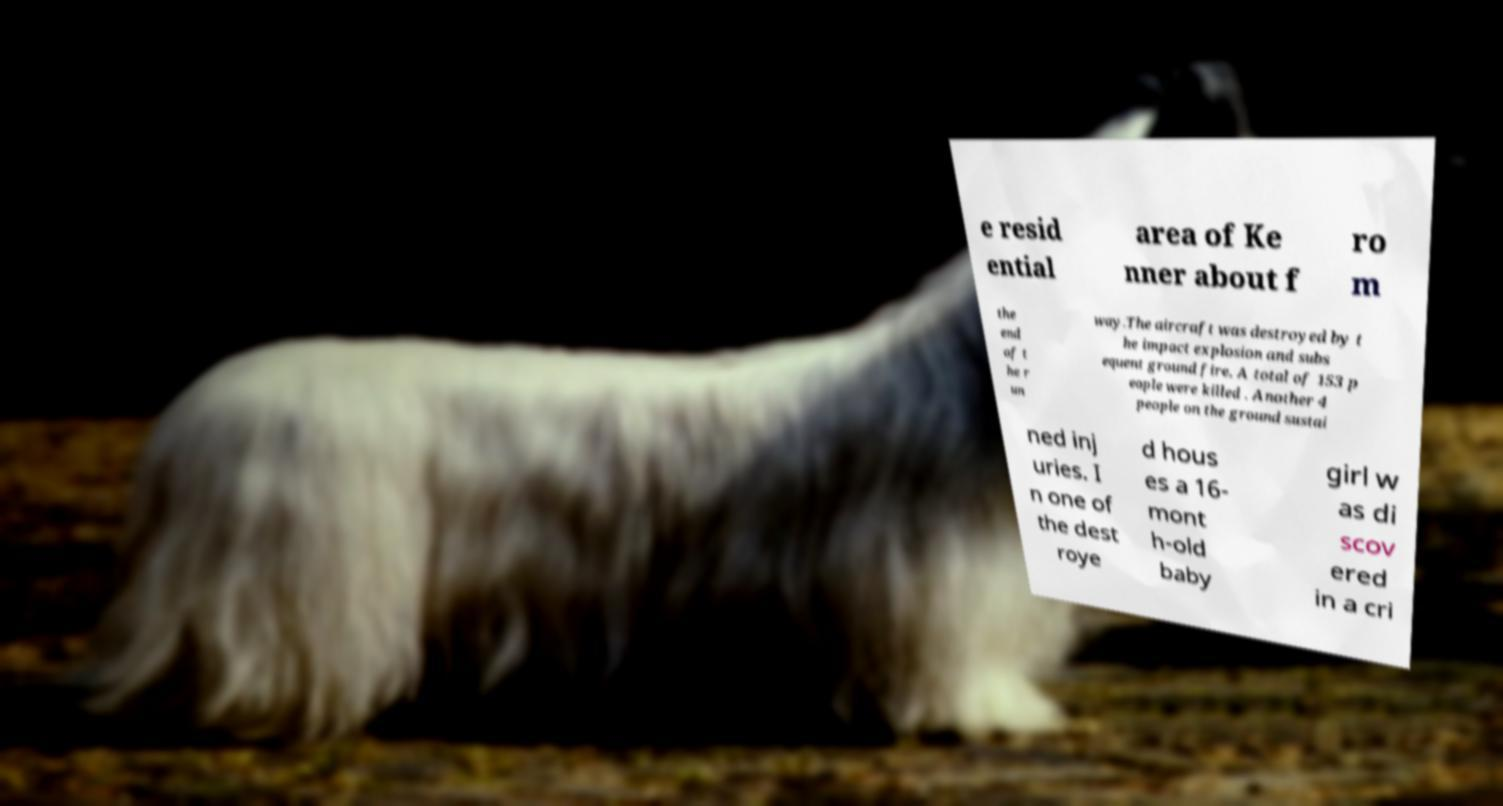What messages or text are displayed in this image? I need them in a readable, typed format. e resid ential area of Ke nner about f ro m the end of t he r un way.The aircraft was destroyed by t he impact explosion and subs equent ground fire. A total of 153 p eople were killed . Another 4 people on the ground sustai ned inj uries. I n one of the dest roye d hous es a 16- mont h-old baby girl w as di scov ered in a cri 